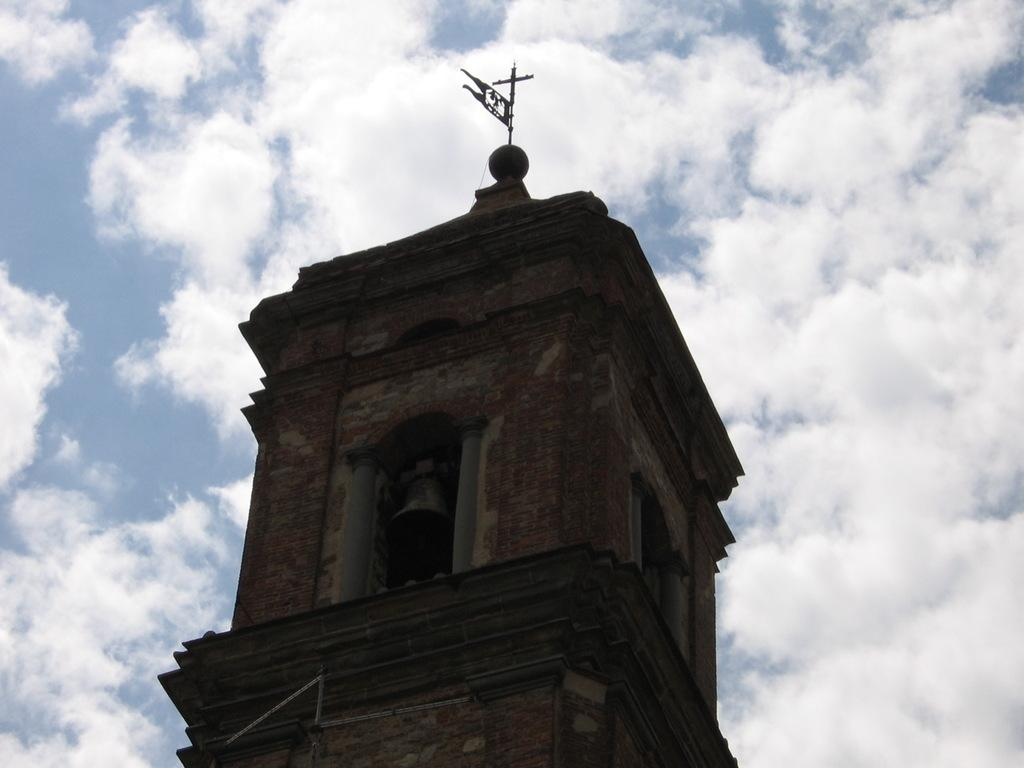What is the main feature of the image? The center of the image contains the sky. What can be seen in the sky? Clouds are visible in the sky. How many buildings are present in the image? There is one building in the image. What objects are present in the image that are related to sound or signaling? A bell and a flag are present in the image. What religious symbol is visible in the image? A cross is visible in the image. What type of cream is being used to cut the vegetables in the image? There is no cream or vegetables present in the image; it primarily features the sky, clouds, a building, a bell, a cross, and a flag. 